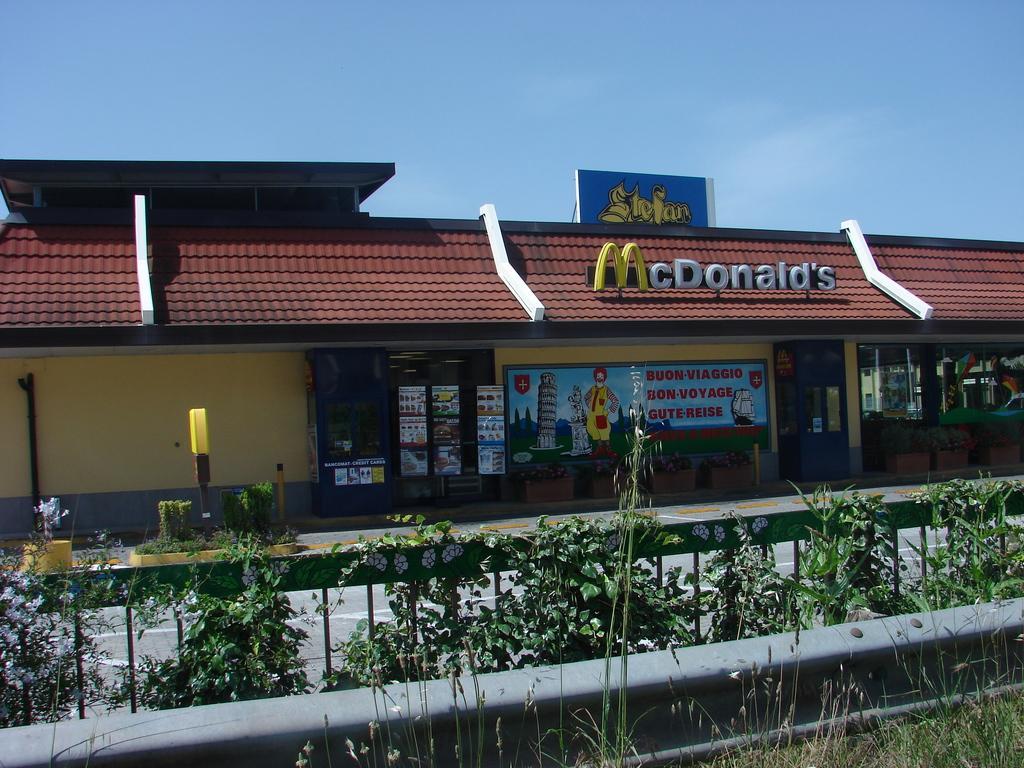Describe this image in one or two sentences. This picture is clicked outside. In the foreground we can see the green grass, plants and the fence and there is a building on which we can see the pictures of buildings and a person and we can see the text is written on the building. In the background there is a sky. 